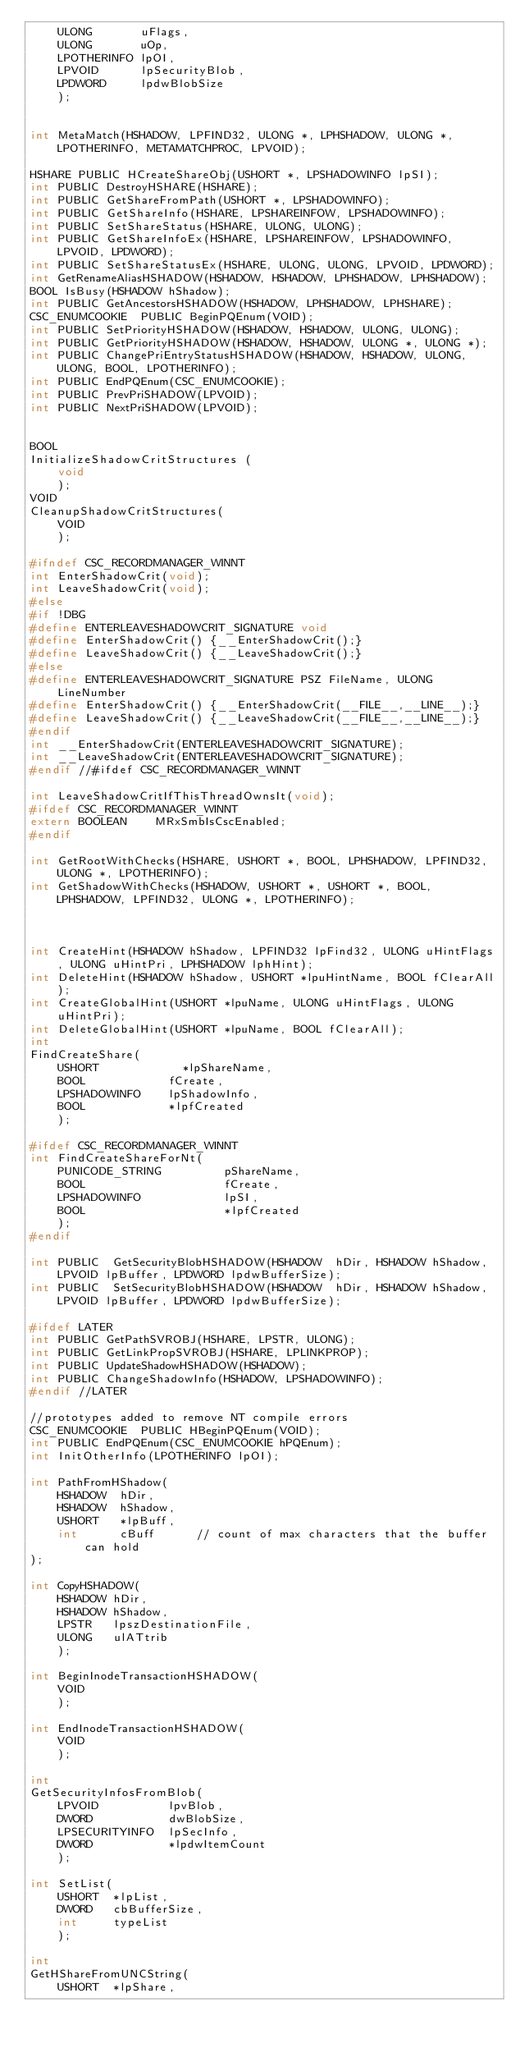<code> <loc_0><loc_0><loc_500><loc_500><_C_>    ULONG       uFlags,
    ULONG       uOp,
    LPOTHERINFO lpOI,
    LPVOID      lpSecurityBlob,
    LPDWORD     lpdwBlobSize
    );


int MetaMatch(HSHADOW, LPFIND32, ULONG *, LPHSHADOW, ULONG *, LPOTHERINFO, METAMATCHPROC, LPVOID);

HSHARE PUBLIC HCreateShareObj(USHORT *, LPSHADOWINFO lpSI);
int PUBLIC DestroyHSHARE(HSHARE);
int PUBLIC GetShareFromPath(USHORT *, LPSHADOWINFO);
int PUBLIC GetShareInfo(HSHARE, LPSHAREINFOW, LPSHADOWINFO);
int PUBLIC SetShareStatus(HSHARE, ULONG, ULONG);
int PUBLIC GetShareInfoEx(HSHARE, LPSHAREINFOW, LPSHADOWINFO, LPVOID, LPDWORD);
int PUBLIC SetShareStatusEx(HSHARE, ULONG, ULONG, LPVOID, LPDWORD);
int GetRenameAliasHSHADOW(HSHADOW, HSHADOW, LPHSHADOW, LPHSHADOW);
BOOL IsBusy(HSHADOW hShadow);
int PUBLIC GetAncestorsHSHADOW(HSHADOW, LPHSHADOW, LPHSHARE);
CSC_ENUMCOOKIE  PUBLIC BeginPQEnum(VOID);
int PUBLIC SetPriorityHSHADOW(HSHADOW, HSHADOW, ULONG, ULONG);
int PUBLIC GetPriorityHSHADOW(HSHADOW, HSHADOW, ULONG *, ULONG *);
int PUBLIC ChangePriEntryStatusHSHADOW(HSHADOW, HSHADOW, ULONG, ULONG, BOOL, LPOTHERINFO);
int PUBLIC EndPQEnum(CSC_ENUMCOOKIE);
int PUBLIC PrevPriSHADOW(LPVOID);
int PUBLIC NextPriSHADOW(LPVOID);


BOOL
InitializeShadowCritStructures (
    void
    );
VOID
CleanupShadowCritStructures(
    VOID
    );

#ifndef CSC_RECORDMANAGER_WINNT
int EnterShadowCrit(void);
int LeaveShadowCrit(void);
#else
#if !DBG
#define ENTERLEAVESHADOWCRIT_SIGNATURE void
#define EnterShadowCrit() {__EnterShadowCrit();}
#define LeaveShadowCrit() {__LeaveShadowCrit();}
#else
#define ENTERLEAVESHADOWCRIT_SIGNATURE PSZ FileName, ULONG LineNumber
#define EnterShadowCrit() {__EnterShadowCrit(__FILE__,__LINE__);}
#define LeaveShadowCrit() {__LeaveShadowCrit(__FILE__,__LINE__);}
#endif
int __EnterShadowCrit(ENTERLEAVESHADOWCRIT_SIGNATURE);
int __LeaveShadowCrit(ENTERLEAVESHADOWCRIT_SIGNATURE);
#endif //#ifdef CSC_RECORDMANAGER_WINNT

int LeaveShadowCritIfThisThreadOwnsIt(void);
#ifdef CSC_RECORDMANAGER_WINNT
extern BOOLEAN    MRxSmbIsCscEnabled;
#endif

int GetRootWithChecks(HSHARE, USHORT *, BOOL, LPHSHADOW, LPFIND32, ULONG *, LPOTHERINFO);
int GetShadowWithChecks(HSHADOW, USHORT *, USHORT *, BOOL, LPHSHADOW, LPFIND32, ULONG *, LPOTHERINFO);



int CreateHint(HSHADOW hShadow, LPFIND32 lpFind32, ULONG uHintFlags, ULONG uHintPri, LPHSHADOW lphHint);
int DeleteHint(HSHADOW hShadow, USHORT *lpuHintName, BOOL fClearAll);
int CreateGlobalHint(USHORT *lpuName, ULONG uHintFlags, ULONG uHintPri);
int DeleteGlobalHint(USHORT *lpuName, BOOL fClearAll);
int
FindCreateShare(
    USHORT            *lpShareName,
    BOOL            fCreate,
    LPSHADOWINFO    lpShadowInfo,
    BOOL            *lpfCreated
    );

#ifdef CSC_RECORDMANAGER_WINNT
int FindCreateShareForNt(
    PUNICODE_STRING         pShareName,
    BOOL                    fCreate,
    LPSHADOWINFO            lpSI,
    BOOL                    *lpfCreated
    );
#endif

int PUBLIC  GetSecurityBlobHSHADOW(HSHADOW  hDir, HSHADOW hShadow, LPVOID lpBuffer, LPDWORD lpdwBufferSize);
int PUBLIC  SetSecurityBlobHSHADOW(HSHADOW  hDir, HSHADOW hShadow, LPVOID lpBuffer, LPDWORD lpdwBufferSize);

#ifdef LATER
int PUBLIC GetPathSVROBJ(HSHARE, LPSTR, ULONG);
int PUBLIC GetLinkPropSVROBJ(HSHARE, LPLINKPROP);
int PUBLIC UpdateShadowHSHADOW(HSHADOW);
int PUBLIC ChangeShadowInfo(HSHADOW, LPSHADOWINFO);
#endif //LATER

//prototypes added to remove NT compile errors
CSC_ENUMCOOKIE  PUBLIC HBeginPQEnum(VOID);
int PUBLIC EndPQEnum(CSC_ENUMCOOKIE hPQEnum);
int InitOtherInfo(LPOTHERINFO lpOI);

int PathFromHShadow(
    HSHADOW  hDir,
    HSHADOW  hShadow,
    USHORT   *lpBuff,
    int      cBuff      // count of max characters that the buffer can hold
);

int CopyHSHADOW(
    HSHADOW hDir,
    HSHADOW hShadow,
    LPSTR   lpszDestinationFile,
    ULONG   ulATtrib
    );

int BeginInodeTransactionHSHADOW(
    VOID
    );

int EndInodeTransactionHSHADOW(
    VOID
    );

int
GetSecurityInfosFromBlob(
    LPVOID          lpvBlob,
    DWORD           dwBlobSize,
    LPSECURITYINFO  lpSecInfo,
    DWORD           *lpdwItemCount
    );

int SetList(
    USHORT  *lpList,
    DWORD   cbBufferSize,
    int     typeList
    );

int
GetHShareFromUNCString(
    USHORT  *lpShare,</code> 